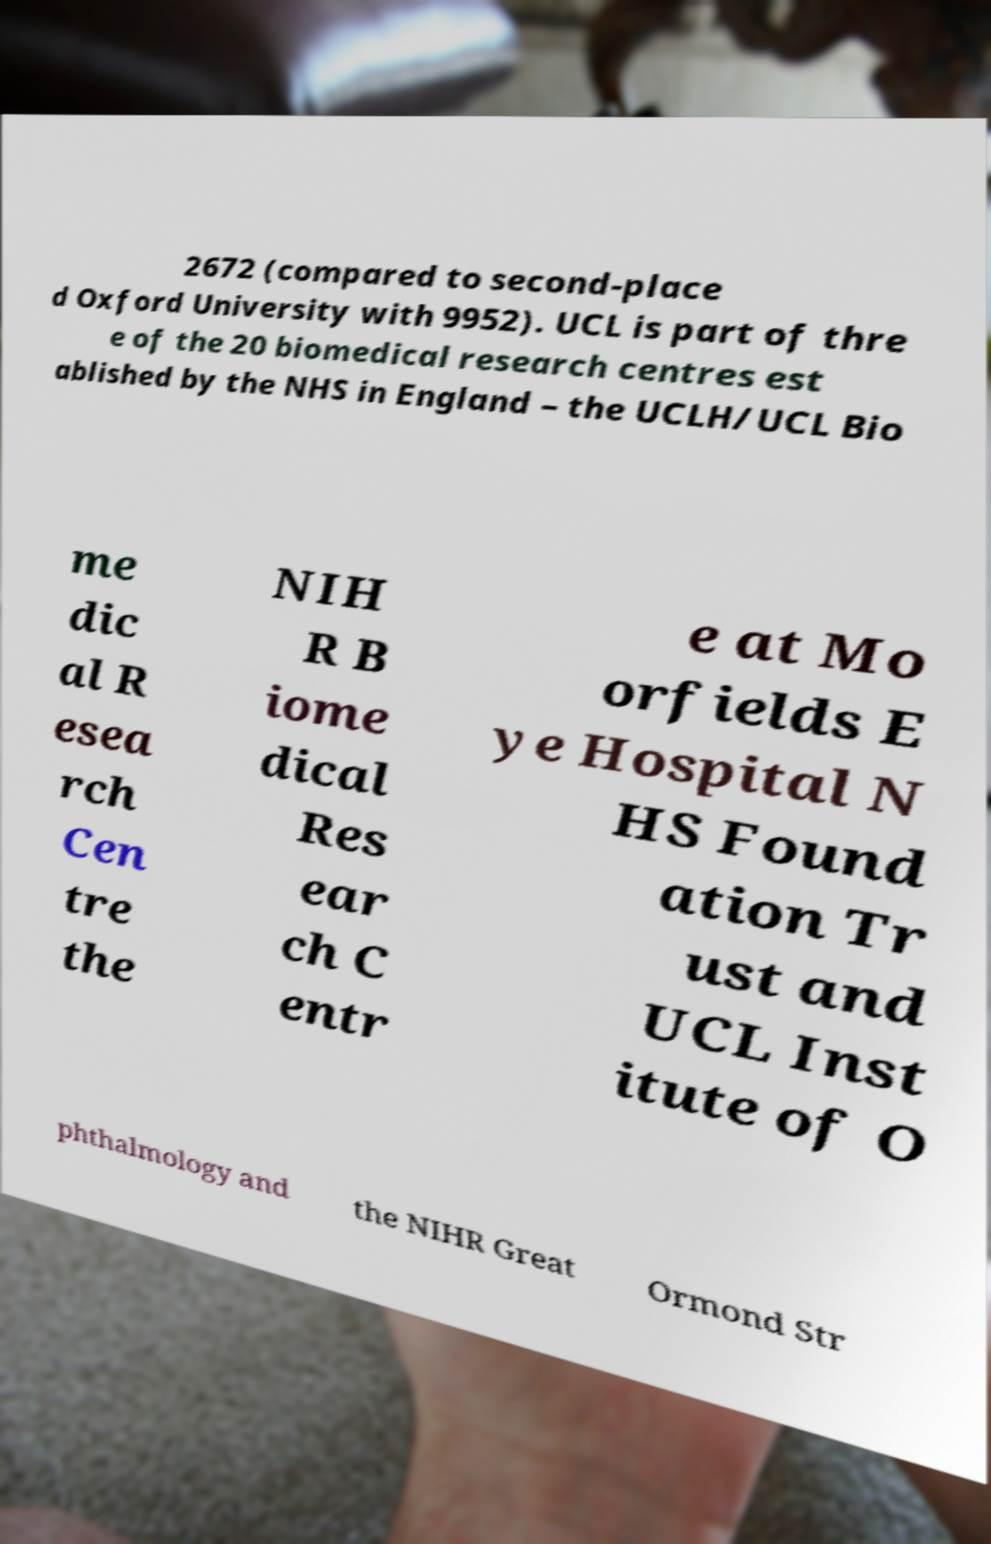Please identify and transcribe the text found in this image. 2672 (compared to second-place d Oxford University with 9952). UCL is part of thre e of the 20 biomedical research centres est ablished by the NHS in England – the UCLH/UCL Bio me dic al R esea rch Cen tre the NIH R B iome dical Res ear ch C entr e at Mo orfields E ye Hospital N HS Found ation Tr ust and UCL Inst itute of O phthalmology and the NIHR Great Ormond Str 